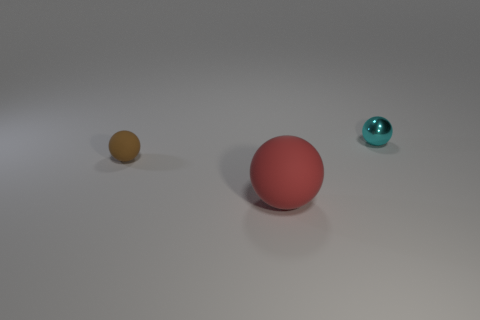Subtract all big red balls. How many balls are left? 2 Subtract all red spheres. How many spheres are left? 2 Add 3 brown balls. How many objects exist? 6 Subtract all cyan balls. Subtract all tiny objects. How many objects are left? 0 Add 1 brown rubber balls. How many brown rubber balls are left? 2 Add 1 small blue matte balls. How many small blue matte balls exist? 1 Subtract 0 green balls. How many objects are left? 3 Subtract 2 spheres. How many spheres are left? 1 Subtract all cyan balls. Subtract all cyan cubes. How many balls are left? 2 Subtract all red cylinders. How many red spheres are left? 1 